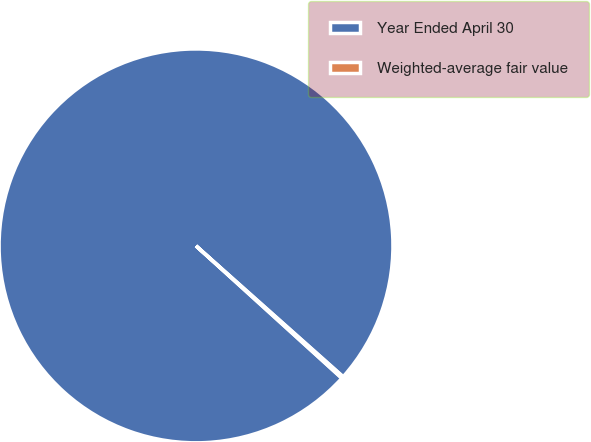Convert chart. <chart><loc_0><loc_0><loc_500><loc_500><pie_chart><fcel>Year Ended April 30<fcel>Weighted-average fair value<nl><fcel>99.84%<fcel>0.16%<nl></chart> 